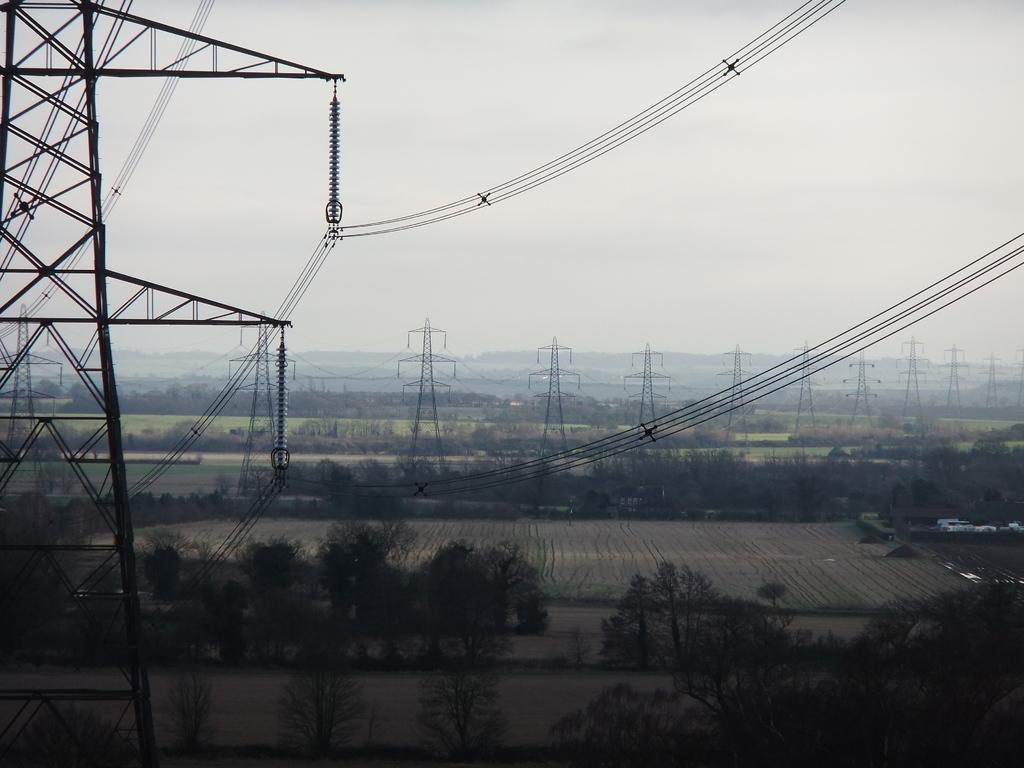In one or two sentences, can you explain what this image depicts? In this image we can see a group of trees, fields and towers with wires. On the left side, we can see a tower and wires. At the top we can see the sky. 